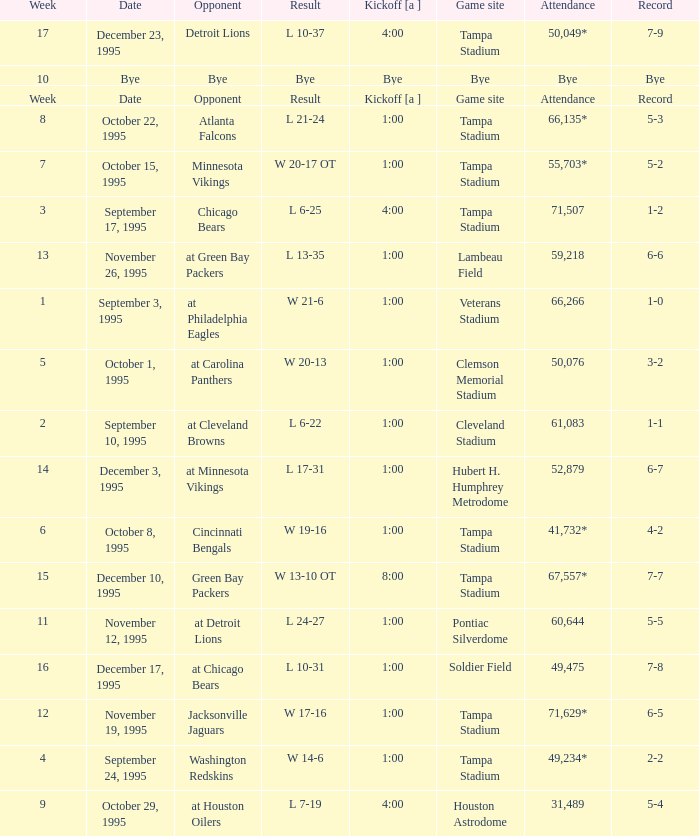What week was it on November 19, 1995? 12.0. 